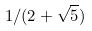<formula> <loc_0><loc_0><loc_500><loc_500>1 / ( 2 + \sqrt { 5 } )</formula> 